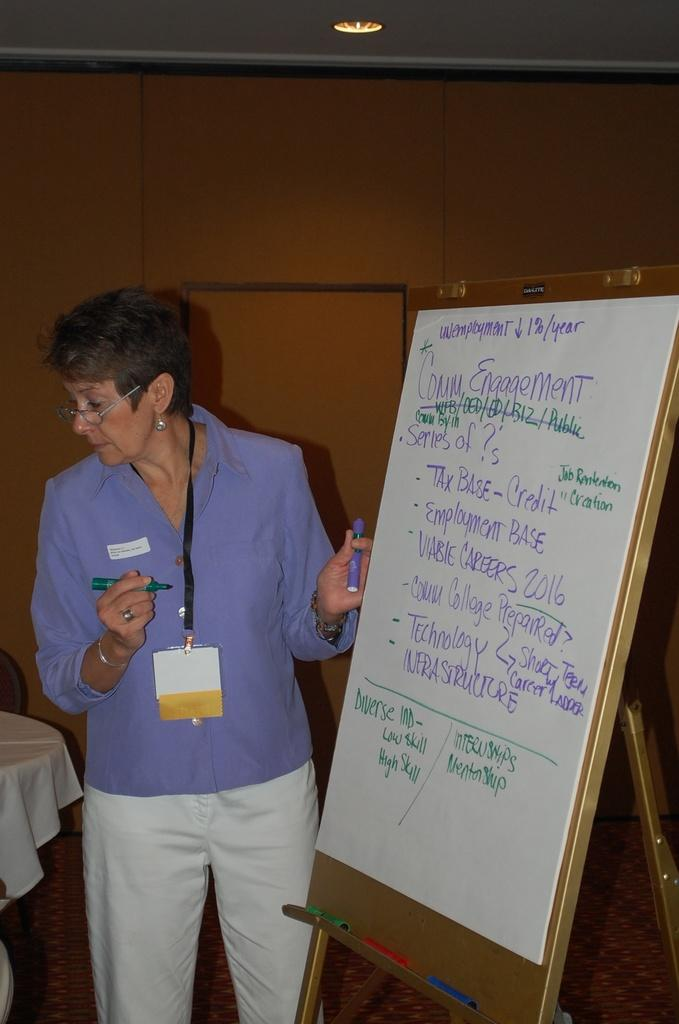Who is present in the image? There is a woman in the image. What is the woman doing in the image? The woman is standing beside a board and holding a pen. What can be seen on the left side of the image? There is a table on the left side of the image. How is the table decorated or covered? The table is covered with a white cloth. What type of bread is being served in a bowl of soup in the image? There is no bread or soup present in the image. How many chairs are visible in the image? There is no chair visible in the image. 